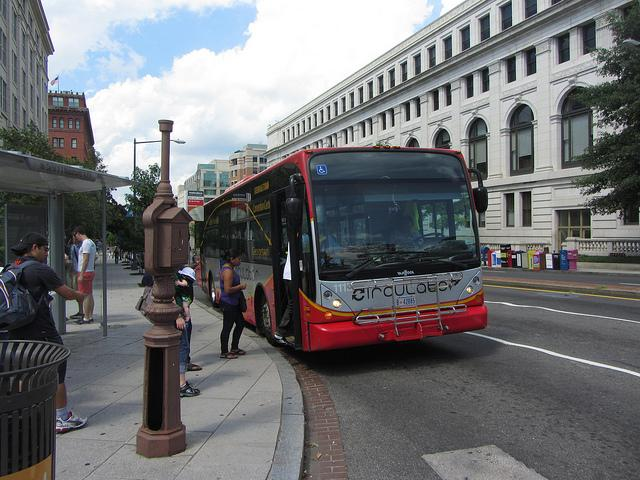What special group of people are accommodated in the bus? Please explain your reasoning. handicapped. The handicapped people can ride on this bus because there is a handicapped sign on it 